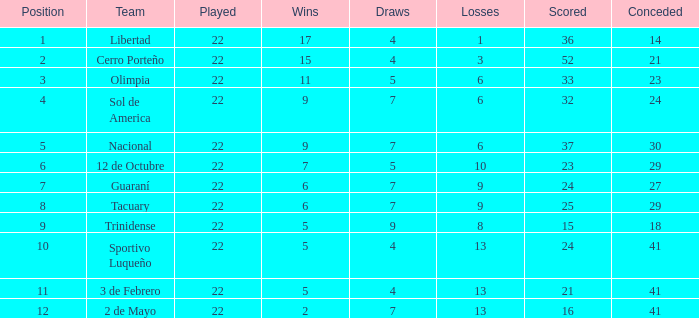For a team with more than 8 losses and a total of 13 points, what is their draw count? 7.0. 